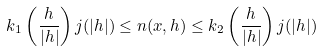<formula> <loc_0><loc_0><loc_500><loc_500>k _ { 1 } \left ( \frac { h } { | h | } \right ) j ( | h | ) \leq n ( x , h ) \leq k _ { 2 } \left ( \frac { h } { | h | } \right ) j ( | h | ) \,</formula> 